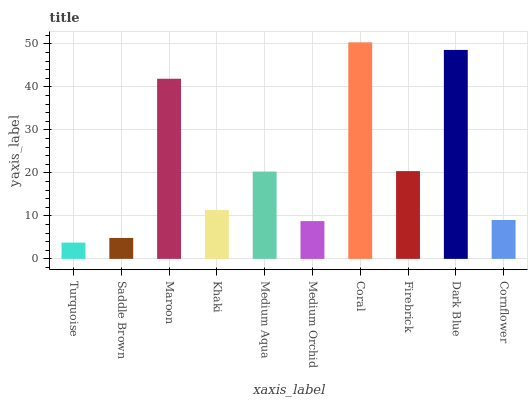Is Saddle Brown the minimum?
Answer yes or no. No. Is Saddle Brown the maximum?
Answer yes or no. No. Is Saddle Brown greater than Turquoise?
Answer yes or no. Yes. Is Turquoise less than Saddle Brown?
Answer yes or no. Yes. Is Turquoise greater than Saddle Brown?
Answer yes or no. No. Is Saddle Brown less than Turquoise?
Answer yes or no. No. Is Medium Aqua the high median?
Answer yes or no. Yes. Is Khaki the low median?
Answer yes or no. Yes. Is Firebrick the high median?
Answer yes or no. No. Is Dark Blue the low median?
Answer yes or no. No. 